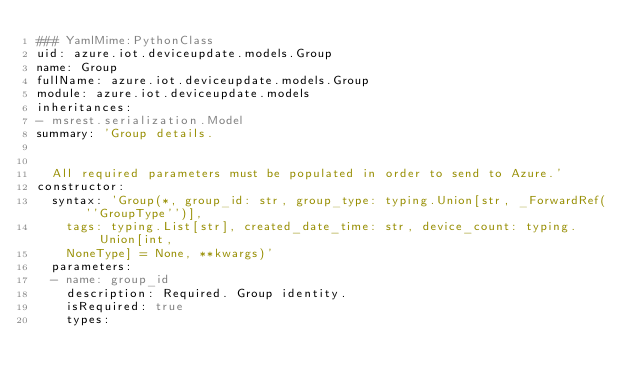<code> <loc_0><loc_0><loc_500><loc_500><_YAML_>### YamlMime:PythonClass
uid: azure.iot.deviceupdate.models.Group
name: Group
fullName: azure.iot.deviceupdate.models.Group
module: azure.iot.deviceupdate.models
inheritances:
- msrest.serialization.Model
summary: 'Group details.


  All required parameters must be populated in order to send to Azure.'
constructor:
  syntax: 'Group(*, group_id: str, group_type: typing.Union[str, _ForwardRef(''GroupType'')],
    tags: typing.List[str], created_date_time: str, device_count: typing.Union[int,
    NoneType] = None, **kwargs)'
  parameters:
  - name: group_id
    description: Required. Group identity.
    isRequired: true
    types:</code> 